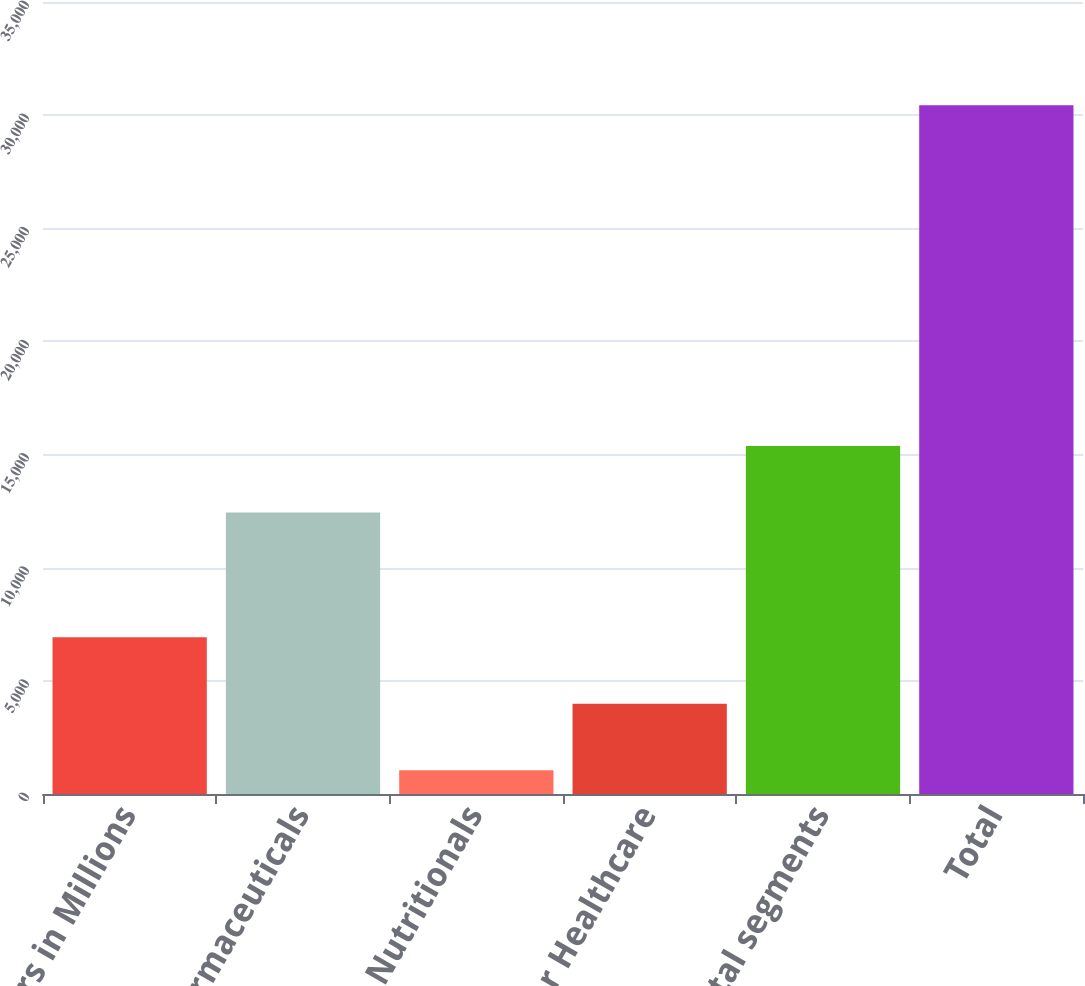Convert chart. <chart><loc_0><loc_0><loc_500><loc_500><bar_chart><fcel>Dollars in Millions<fcel>Pharmaceuticals<fcel>Nutritionals<fcel>Other Healthcare<fcel>Total segments<fcel>Total<nl><fcel>6931<fcel>12436<fcel>1055<fcel>3993<fcel>15374<fcel>30435<nl></chart> 